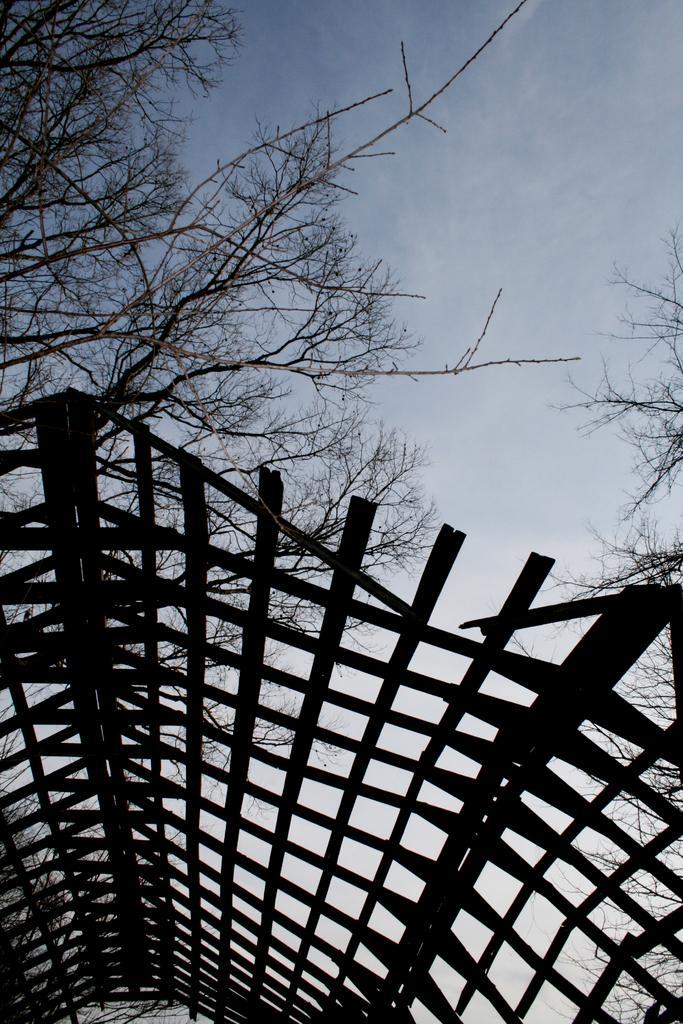Please provide a concise description of this image. It seems like a roof of a shelter at the bottom of this image. We can see trees and the sky is in the background. 